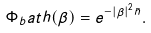Convert formula to latex. <formula><loc_0><loc_0><loc_500><loc_500>\Phi _ { b } a t h ( \beta ) = e ^ { - | \beta | ^ { 2 } \bar { n } } .</formula> 